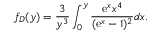Convert formula to latex. <formula><loc_0><loc_0><loc_500><loc_500>f _ { D } ( y ) = \frac { 3 } { y ^ { 3 } } \int _ { 0 } ^ { y } \frac { e ^ { x } x ^ { 4 } } { ( e ^ { x } - 1 ) ^ { 2 } } d x .</formula> 